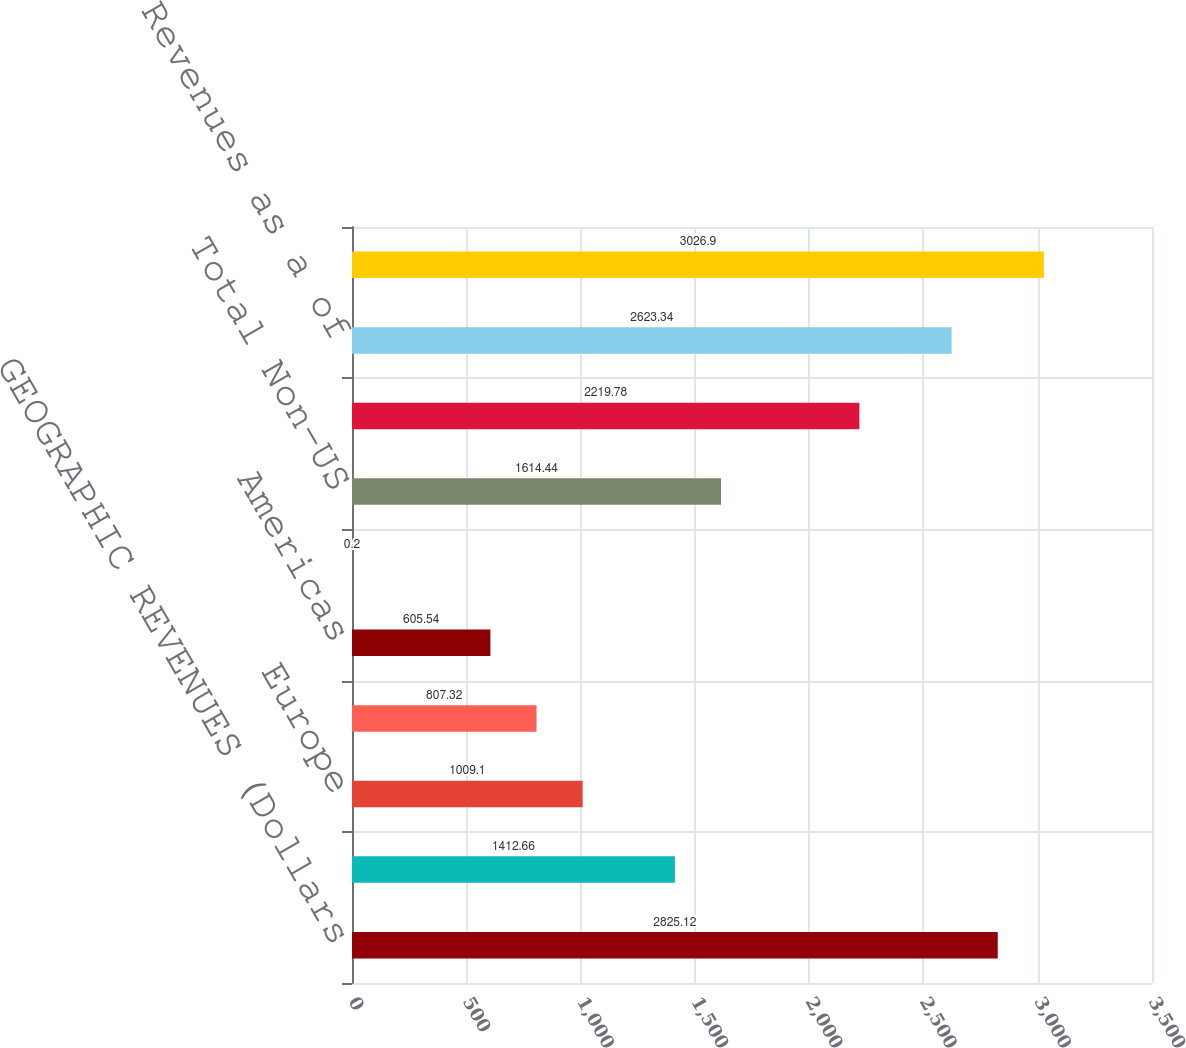<chart> <loc_0><loc_0><loc_500><loc_500><bar_chart><fcel>GEOGRAPHIC REVENUES (Dollars<fcel>US<fcel>Europe<fcel>Asia<fcel>Americas<fcel>Middle East and Africa<fcel>Total Non-US<fcel>Total Segment Revenues<fcel>Non-US Revenues as a of<fcel>SUB-SEGMENT REVENUES (In<nl><fcel>2825.12<fcel>1412.66<fcel>1009.1<fcel>807.32<fcel>605.54<fcel>0.2<fcel>1614.44<fcel>2219.78<fcel>2623.34<fcel>3026.9<nl></chart> 